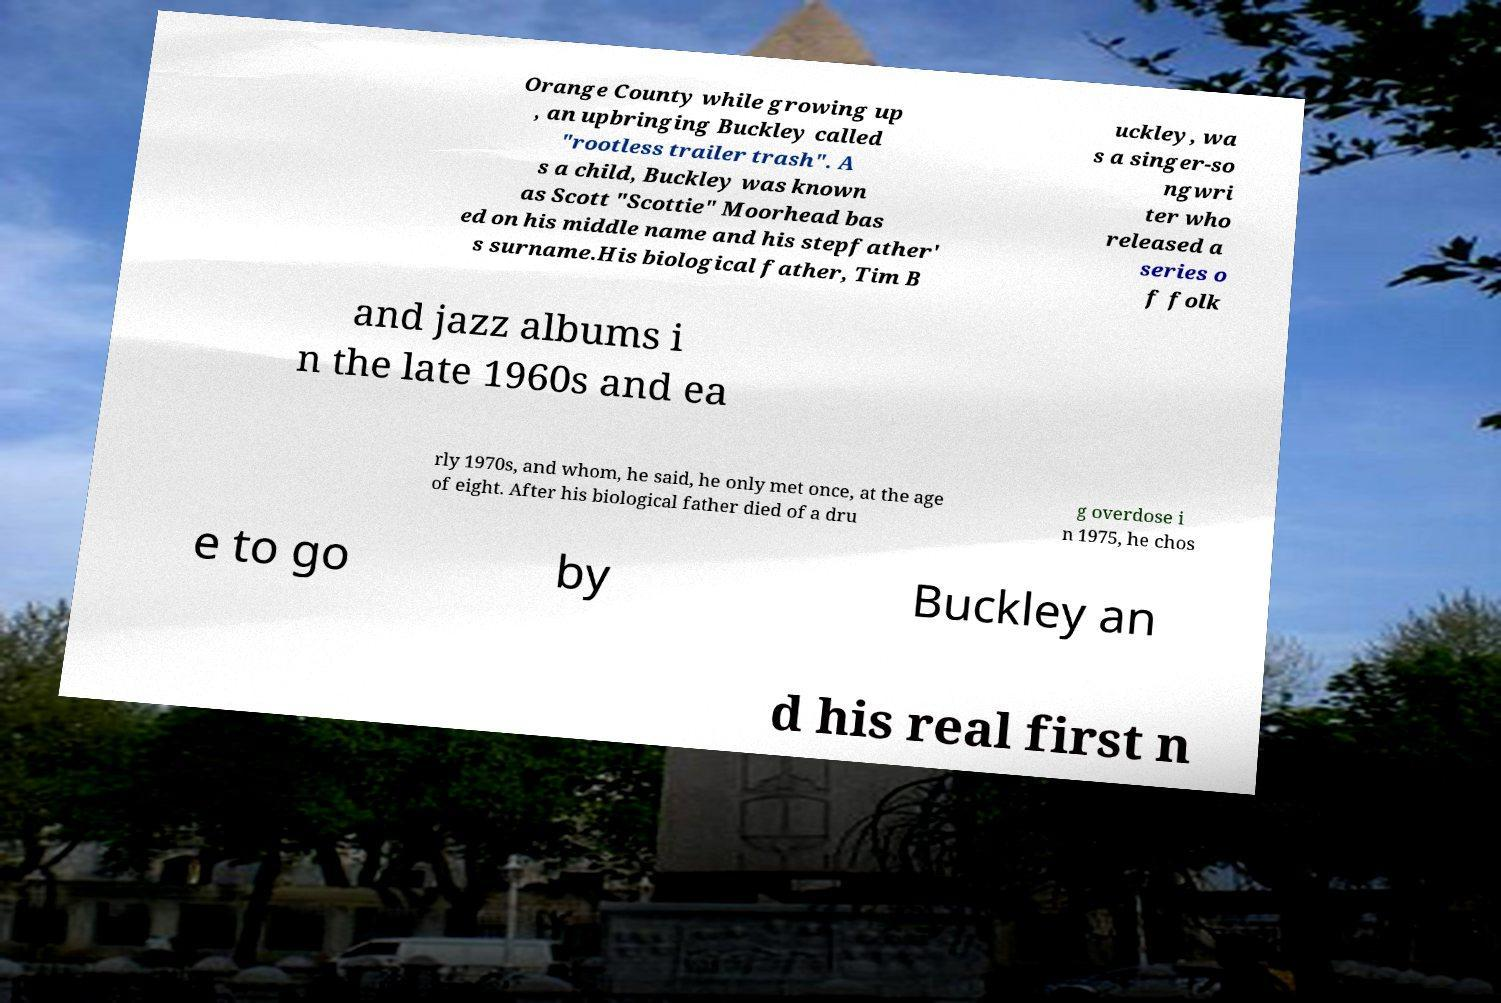What messages or text are displayed in this image? I need them in a readable, typed format. Orange County while growing up , an upbringing Buckley called "rootless trailer trash". A s a child, Buckley was known as Scott "Scottie" Moorhead bas ed on his middle name and his stepfather' s surname.His biological father, Tim B uckley, wa s a singer-so ngwri ter who released a series o f folk and jazz albums i n the late 1960s and ea rly 1970s, and whom, he said, he only met once, at the age of eight. After his biological father died of a dru g overdose i n 1975, he chos e to go by Buckley an d his real first n 